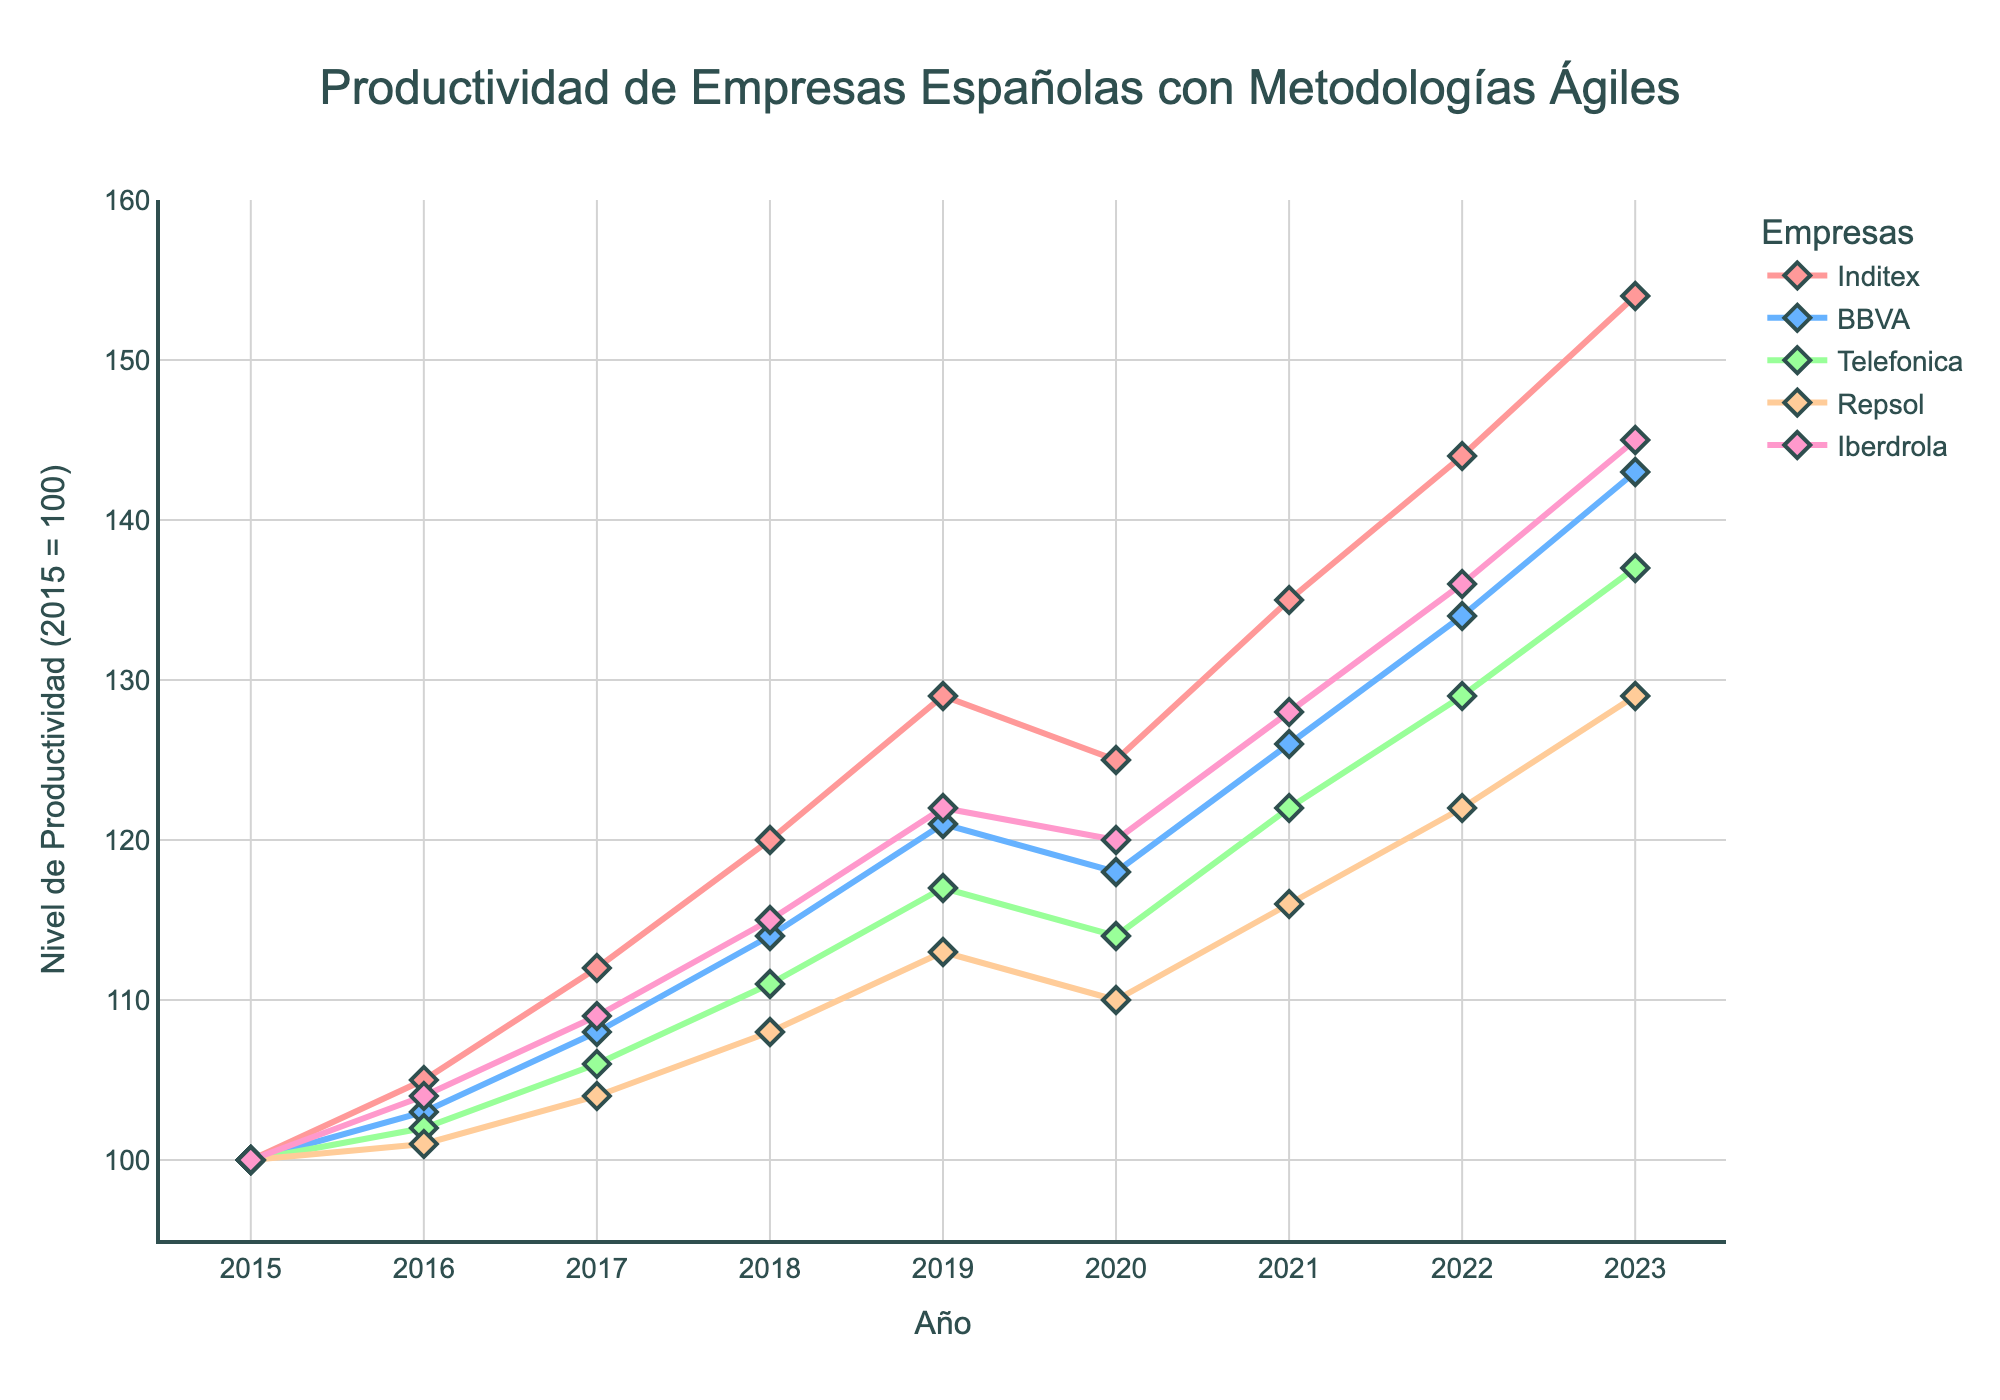What year did Inditex surpass a productivity level of 130? According to the figure, Inditex's productivity level went above 130 in the year 2021.
Answer: 2021 By how much did the productivity of BBVA increase from 2015 to 2023? The productivity level of BBVA in 2015 was 100, and in 2023 it was 143. The difference is 143 - 100.
Answer: 43 Which company had the highest productivity level in 2020? The data shows the productivity levels for each company in 2020. Inditex had the highest level, which was 125.
Answer: Inditex What is the average productivity level of Iberdrola from 2015 to 2023? We calculate the average by summing Iberdrola's productivity levels from 2015 to 2023 and then dividing by the number of years. (100+104+109+115+122+120+128+136+145) / 9 = 122
Answer: 122 By how much did Repsol's productivity level decrease between 2019 and 2020? Repsol's productivity level in 2019 was 113, and in 2020 it was 110. The decrease is 113 - 110.
Answer: 3 At what year did Telefonica surpass a productivity level of 115? By examining the productivity levels, Telefonica surpassed 115 in the year 2021 when it reached 122.
Answer: 2021 Which company showed the most consistent increase in productivity between 2015 and 2023? By examining the slopes of the lines, we see that Inditex's line shows the most consistent year-over-year increase in productivity.
Answer: Inditex Which companies had a decline in productivity between 2019 and 2020? By observing the trends, both Inditex and Telefonica showed a decline in productivity between 2019 and 2020.
Answer: Inditex, Telefonica Which year did all companies experience an increase in productivity compared to the previous year? According to the figure, in 2017, all companies had higher productivity levels than in 2016.
Answer: 2017 What is the difference in the productivity level between BBVA and Repsol in 2023? BBVA's and Repsol's productivity levels in 2023 were 143 and 129, respectively. The difference is 143 - 129.
Answer: 14 